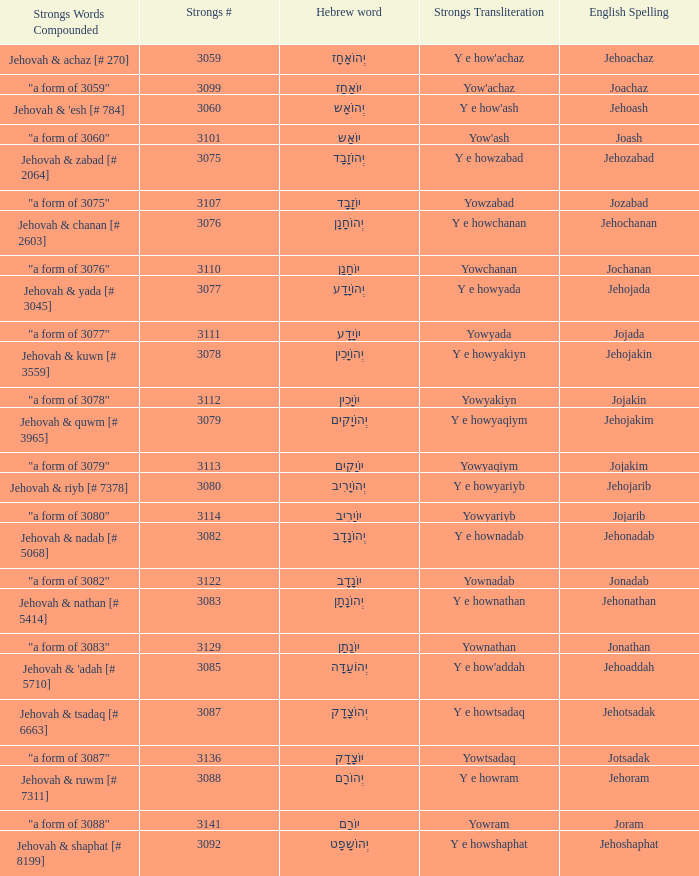What is the strongs transliteration of the hebrew word יוֹחָנָן? Yowchanan. 